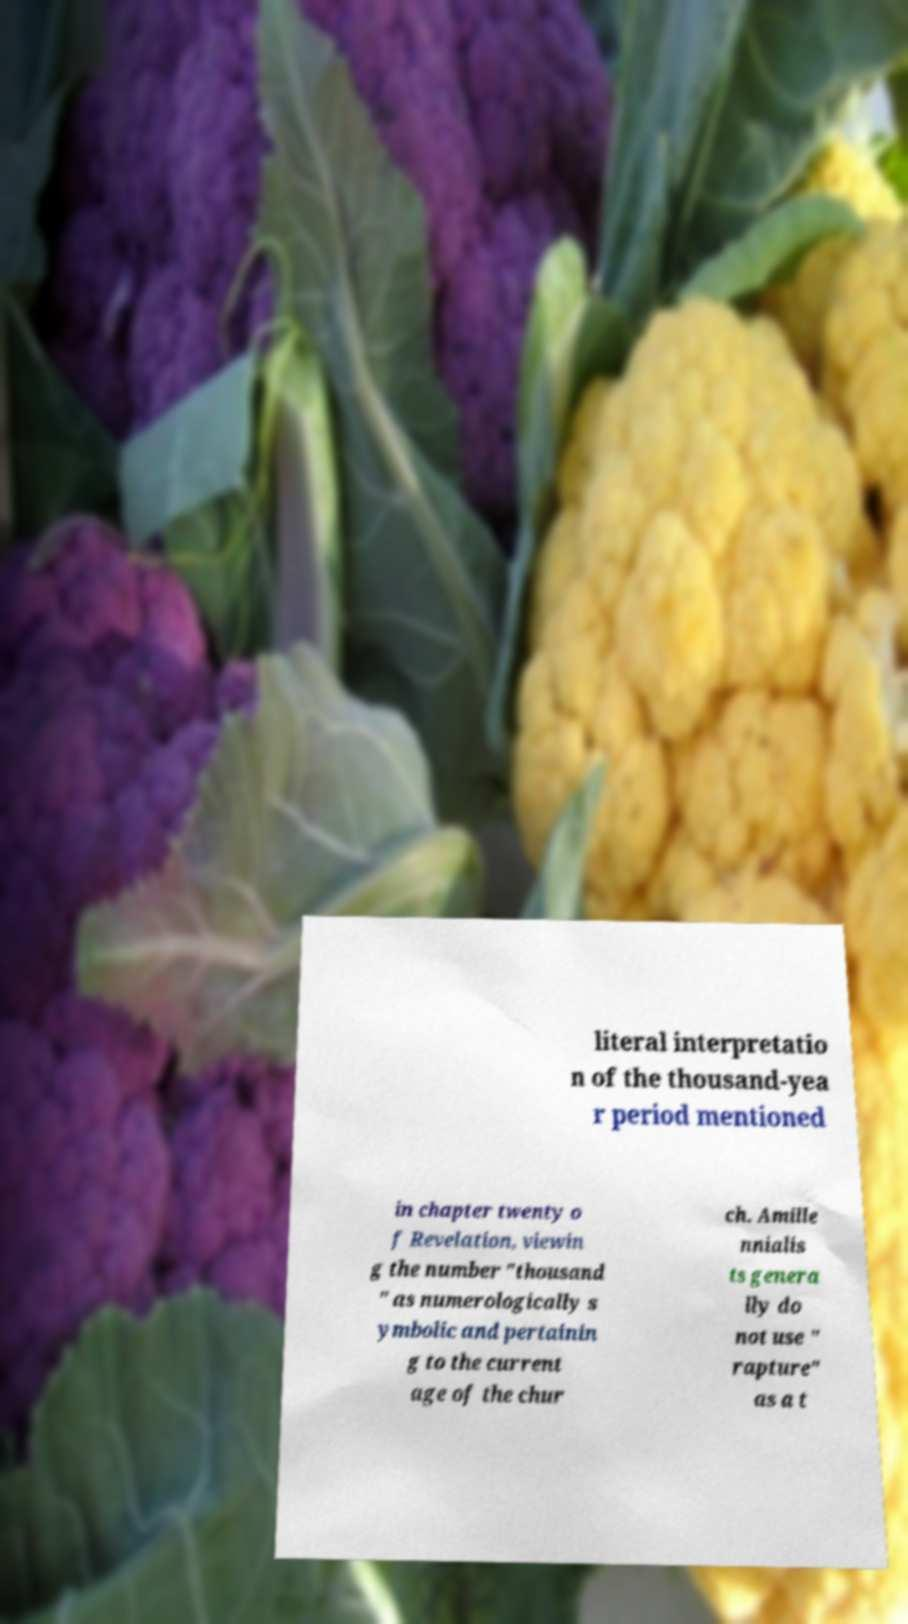There's text embedded in this image that I need extracted. Can you transcribe it verbatim? literal interpretatio n of the thousand-yea r period mentioned in chapter twenty o f Revelation, viewin g the number "thousand " as numerologically s ymbolic and pertainin g to the current age of the chur ch. Amille nnialis ts genera lly do not use " rapture" as a t 